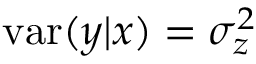Convert formula to latex. <formula><loc_0><loc_0><loc_500><loc_500>v a r ( y | x ) = \sigma _ { z } ^ { 2 }</formula> 